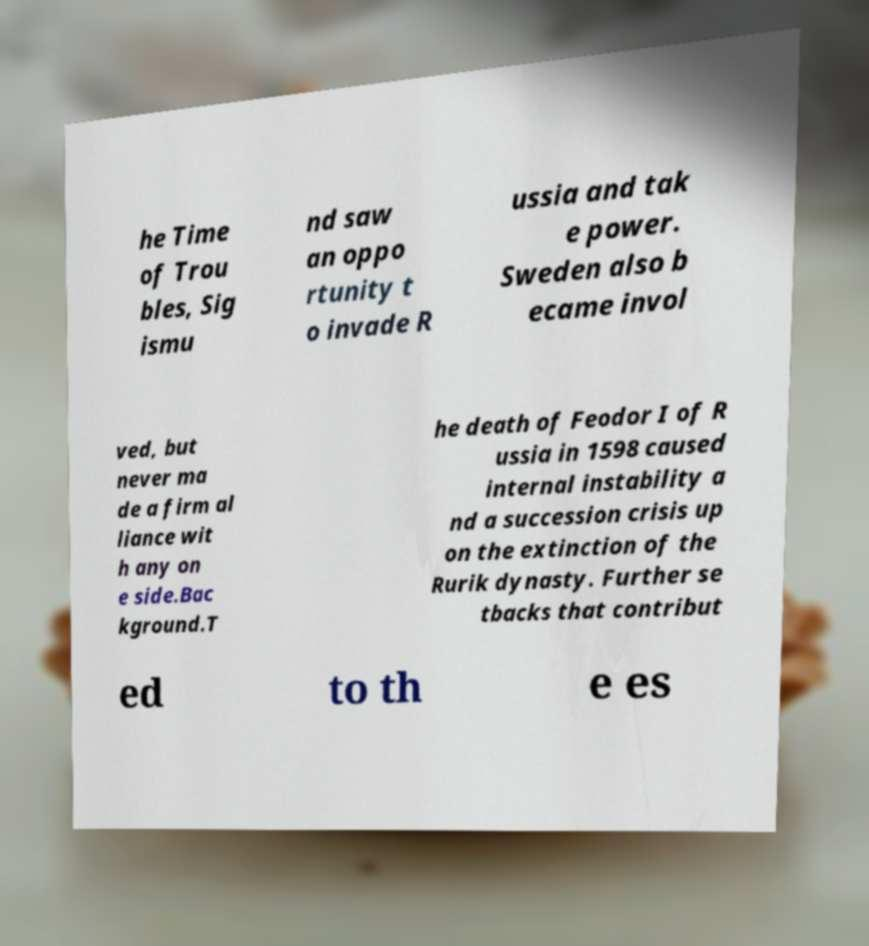There's text embedded in this image that I need extracted. Can you transcribe it verbatim? he Time of Trou bles, Sig ismu nd saw an oppo rtunity t o invade R ussia and tak e power. Sweden also b ecame invol ved, but never ma de a firm al liance wit h any on e side.Bac kground.T he death of Feodor I of R ussia in 1598 caused internal instability a nd a succession crisis up on the extinction of the Rurik dynasty. Further se tbacks that contribut ed to th e es 